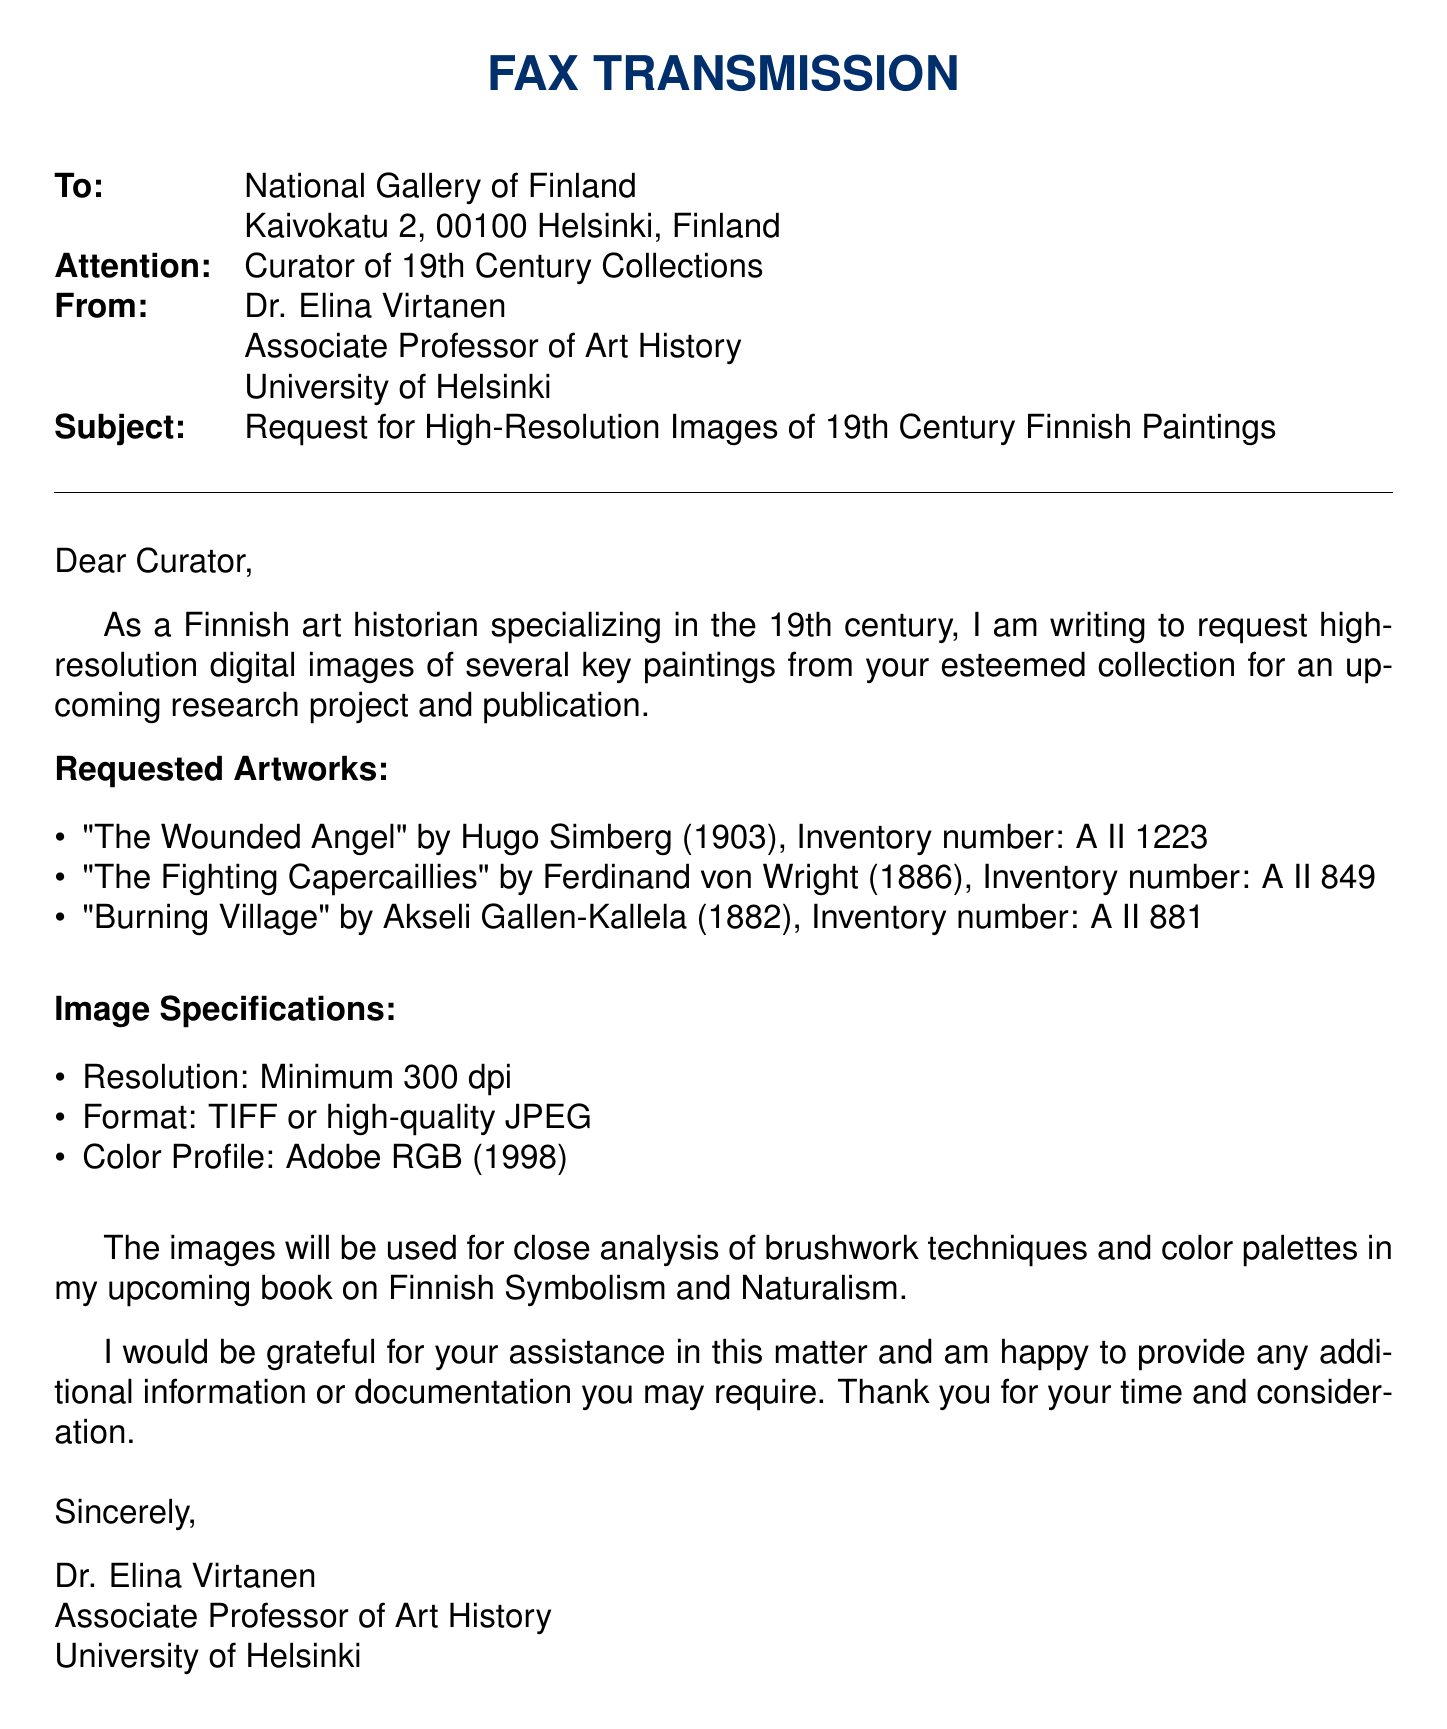What is the subject of the fax? The subject is clearly stated as a request for high-resolution images of 19th Century Finnish Paintings.
Answer: Request for High-Resolution Images of 19th Century Finnish Paintings Who is the sender of the fax? The sender's name and title are listed at the end of the document.
Answer: Dr. Elina Virtanen What is the inventory number for "The Fighting Capercaillies"? The inventory number is provided next to the painting title in the list of requested artworks.
Answer: A II 849 What resolution is specified for the requested images? The image specifications section indicates the required resolution.
Answer: Minimum 300 dpi Which color profile is requested for the images? The specific color profile is mentioned under image specifications.
Answer: Adobe RGB (1998) How many paintings are requested in total? The total number of paintings can be counted in the list of requested artworks.
Answer: Three What is the purpose of the requested images? The sender explains the intended use of the images in the document.
Answer: Close analysis of brushwork techniques and color palettes In which city is the National Gallery located? The location of the National Gallery is provided in the address section.
Answer: Helsinki What year was "The Wounded Angel" painted? The year of creation is mentioned next to the painting title in the requested list.
Answer: 1903 